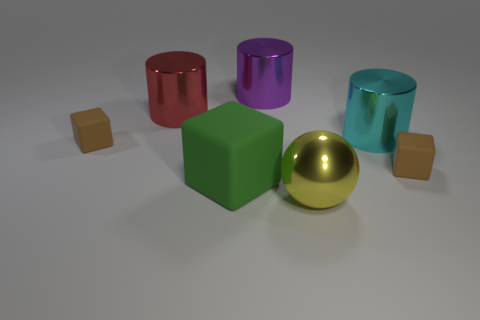Is the number of small brown matte blocks that are on the right side of the cyan metal thing the same as the number of green matte things that are right of the yellow object?
Ensure brevity in your answer.  No. Is there a small matte object left of the brown matte object that is right of the big metallic cylinder in front of the red metal thing?
Make the answer very short. Yes. Is the shape of the brown object that is to the left of the large yellow ball the same as the tiny brown matte object that is on the right side of the big cyan object?
Offer a terse response. Yes. Is the number of metallic cylinders in front of the big purple metallic thing greater than the number of tiny gray blocks?
Give a very brief answer. Yes. What number of things are yellow metallic balls or big green rubber objects?
Provide a succinct answer. 2. The large cube is what color?
Provide a succinct answer. Green. How many other things are the same color as the big cube?
Your answer should be very brief. 0. There is a purple metal cylinder; are there any large shiny balls on the right side of it?
Your response must be concise. Yes. There is a small cube that is behind the tiny block to the right of the small brown matte object left of the purple object; what is its color?
Your answer should be very brief. Brown. How many large objects are both behind the big green matte thing and on the right side of the purple metal cylinder?
Keep it short and to the point. 1. 